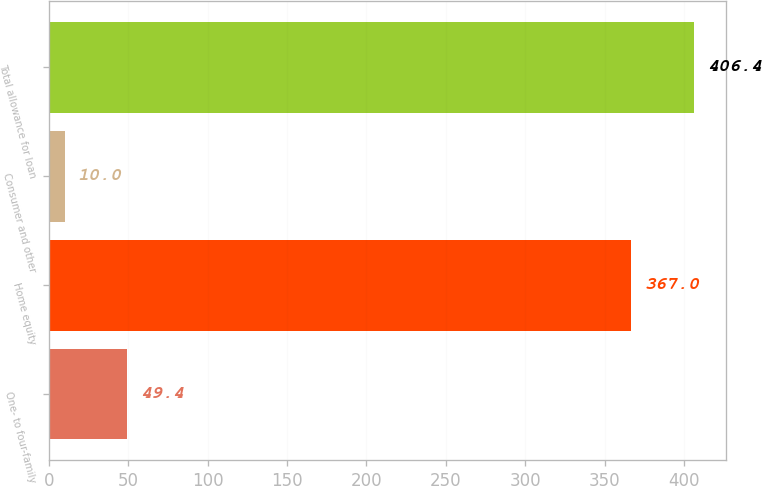<chart> <loc_0><loc_0><loc_500><loc_500><bar_chart><fcel>One- to four-family<fcel>Home equity<fcel>Consumer and other<fcel>Total allowance for loan<nl><fcel>49.4<fcel>367<fcel>10<fcel>406.4<nl></chart> 